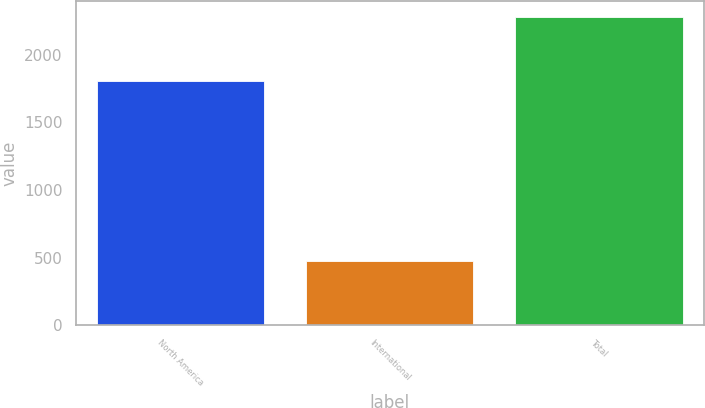Convert chart to OTSL. <chart><loc_0><loc_0><loc_500><loc_500><bar_chart><fcel>North America<fcel>International<fcel>Total<nl><fcel>1809<fcel>474<fcel>2283<nl></chart> 